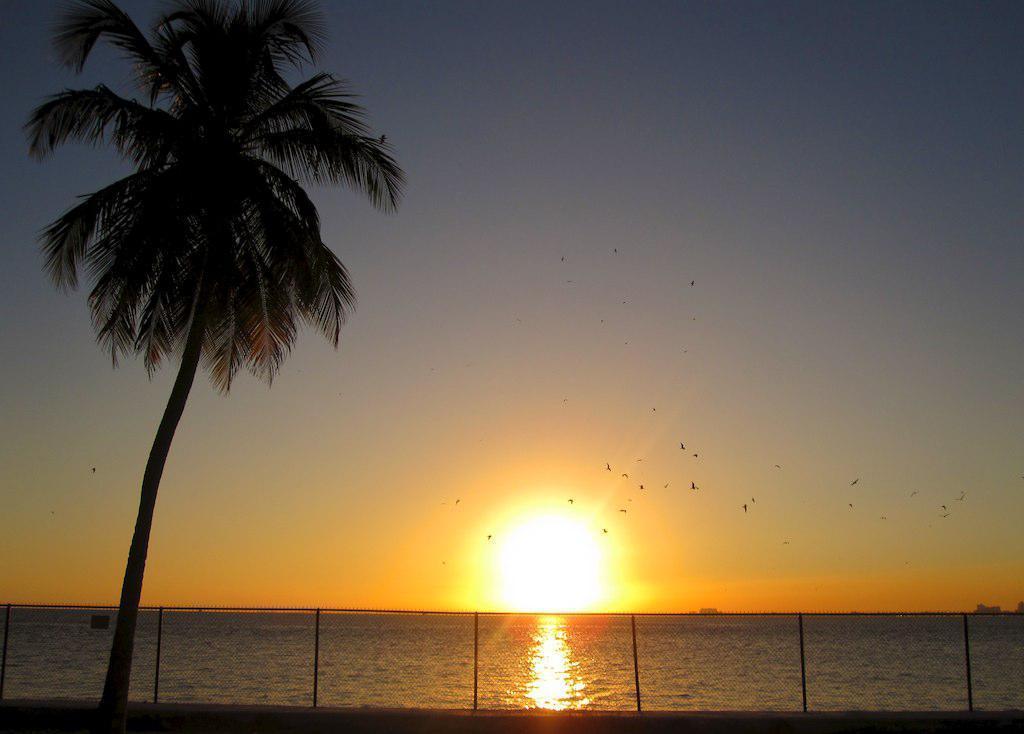How would you summarize this image in a sentence or two? In this image, we can see a mesh, a tree and there is water. In the background, we can see sunset and there are some birds flying in the sky. 